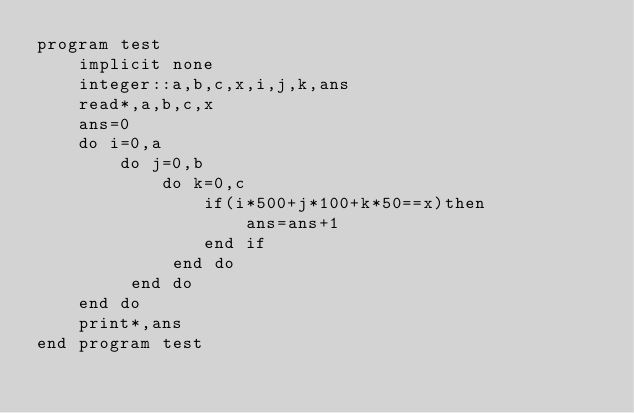Convert code to text. <code><loc_0><loc_0><loc_500><loc_500><_FORTRAN_>program test
	implicit none
    integer::a,b,c,x,i,j,k,ans
    read*,a,b,c,x
    ans=0
    do i=0,a
    	do j=0,b
        	do k=0,c
            	if(i*500+j*100+k*50==x)then
                	ans=ans+1
                end if
             end do
         end do
    end do
    print*,ans
end program test</code> 